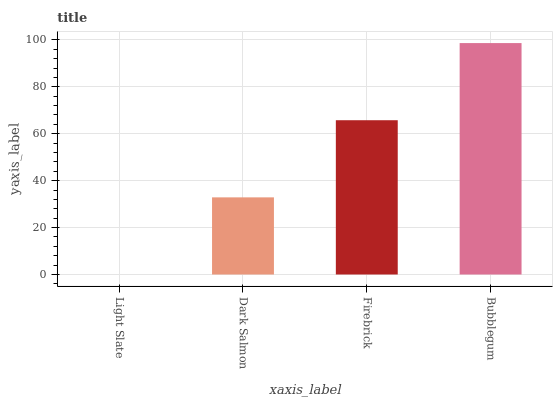Is Light Slate the minimum?
Answer yes or no. Yes. Is Bubblegum the maximum?
Answer yes or no. Yes. Is Dark Salmon the minimum?
Answer yes or no. No. Is Dark Salmon the maximum?
Answer yes or no. No. Is Dark Salmon greater than Light Slate?
Answer yes or no. Yes. Is Light Slate less than Dark Salmon?
Answer yes or no. Yes. Is Light Slate greater than Dark Salmon?
Answer yes or no. No. Is Dark Salmon less than Light Slate?
Answer yes or no. No. Is Firebrick the high median?
Answer yes or no. Yes. Is Dark Salmon the low median?
Answer yes or no. Yes. Is Dark Salmon the high median?
Answer yes or no. No. Is Bubblegum the low median?
Answer yes or no. No. 